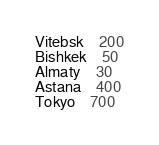Convert code to text. <code><loc_0><loc_0><loc_500><loc_500><_SQL_>Vitebsk	200
Bishkek	50
Almaty	30
Astana	400
Tokyo	700</code> 